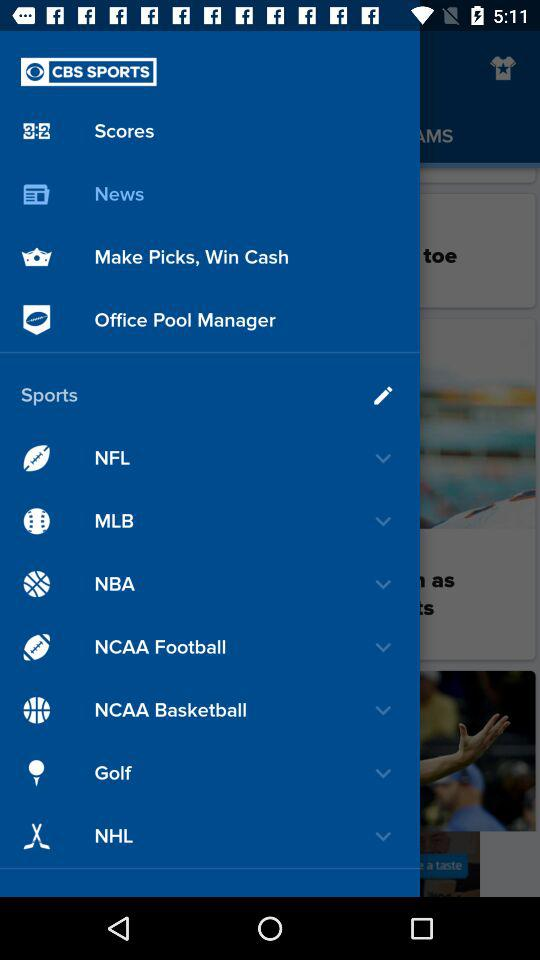What is the application name? The application name is "CBS SPORTS". 